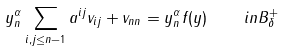Convert formula to latex. <formula><loc_0><loc_0><loc_500><loc_500>y _ { n } ^ { \alpha } \sum _ { i , j \leq n - 1 } a ^ { i j } v _ { i j } + v _ { n n } = y _ { n } ^ { \alpha } f ( y ) \quad i n B _ { \delta } ^ { + }</formula> 